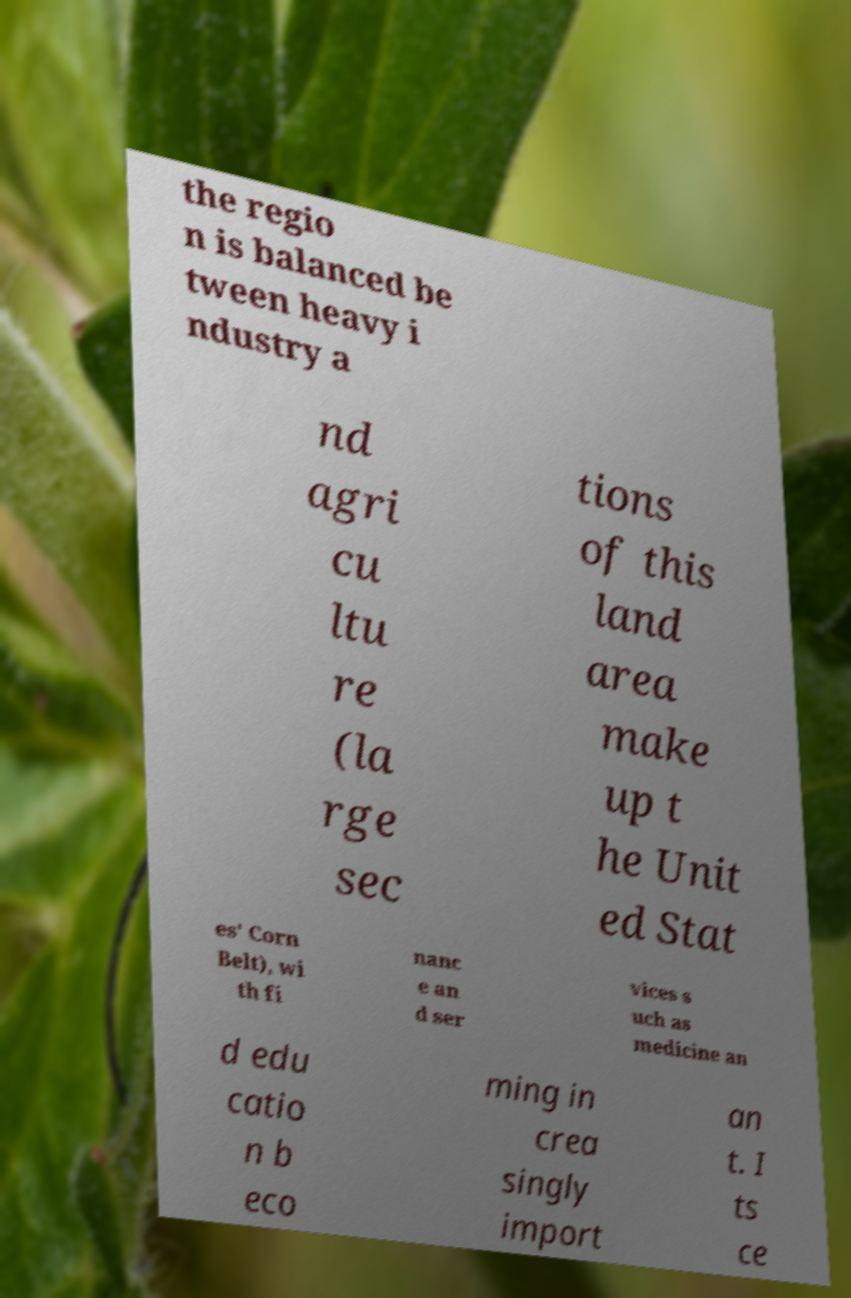What messages or text are displayed in this image? I need them in a readable, typed format. the regio n is balanced be tween heavy i ndustry a nd agri cu ltu re (la rge sec tions of this land area make up t he Unit ed Stat es' Corn Belt), wi th fi nanc e an d ser vices s uch as medicine an d edu catio n b eco ming in crea singly import an t. I ts ce 